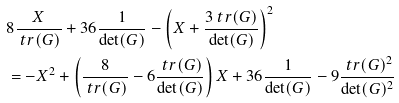<formula> <loc_0><loc_0><loc_500><loc_500>& 8 \frac { X } { \ t r ( G ) } + 3 6 \frac { 1 } { \det ( G ) } - \left ( X + \frac { 3 \ t r ( G ) } { \det ( G ) } \right ) ^ { 2 } \\ & = - X ^ { 2 } + \left ( \frac { 8 } { \ t r ( G ) } - 6 \frac { \ t r ( G ) } { \det ( G ) } \right ) X + 3 6 \frac { 1 } { \det ( G ) } - 9 \frac { \ t r ( G ) ^ { 2 } } { \det ( G ) ^ { 2 } }</formula> 